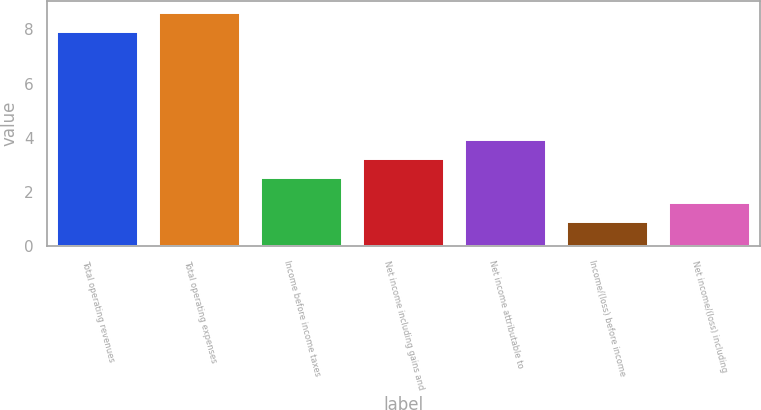Convert chart to OTSL. <chart><loc_0><loc_0><loc_500><loc_500><bar_chart><fcel>Total operating revenues<fcel>Total operating expenses<fcel>Income before income taxes<fcel>Net income including gains and<fcel>Net income attributable to<fcel>Income/(loss) before income<fcel>Net income/(loss) including<nl><fcel>7.9<fcel>8.6<fcel>2.5<fcel>3.2<fcel>3.9<fcel>0.9<fcel>1.6<nl></chart> 